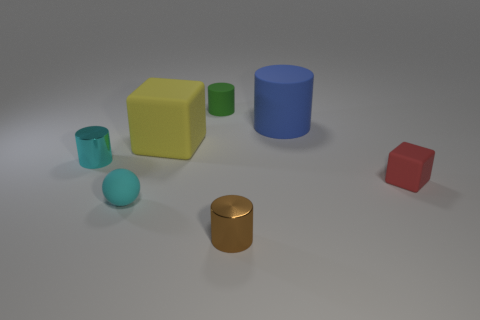What shapes and colors are represented in the objects within this image? This image contains a variety of three-dimensional shapes including cubes, cylinders, and a sphere. The colors present include red, yellow, green, blue, and metallic. 